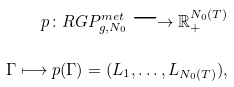<formula> <loc_0><loc_0><loc_500><loc_500>p \colon R G P _ { g , N _ { 0 } } ^ { m e t } \longrightarrow \mathbb { R } _ { + } ^ { N _ { 0 } ( T ) } \\ \Gamma \longmapsto p ( \Gamma ) = ( L _ { 1 } , \dots , L _ { N _ { 0 } ( T ) } ) ,</formula> 